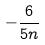Convert formula to latex. <formula><loc_0><loc_0><loc_500><loc_500>- \frac { 6 } { 5 n }</formula> 